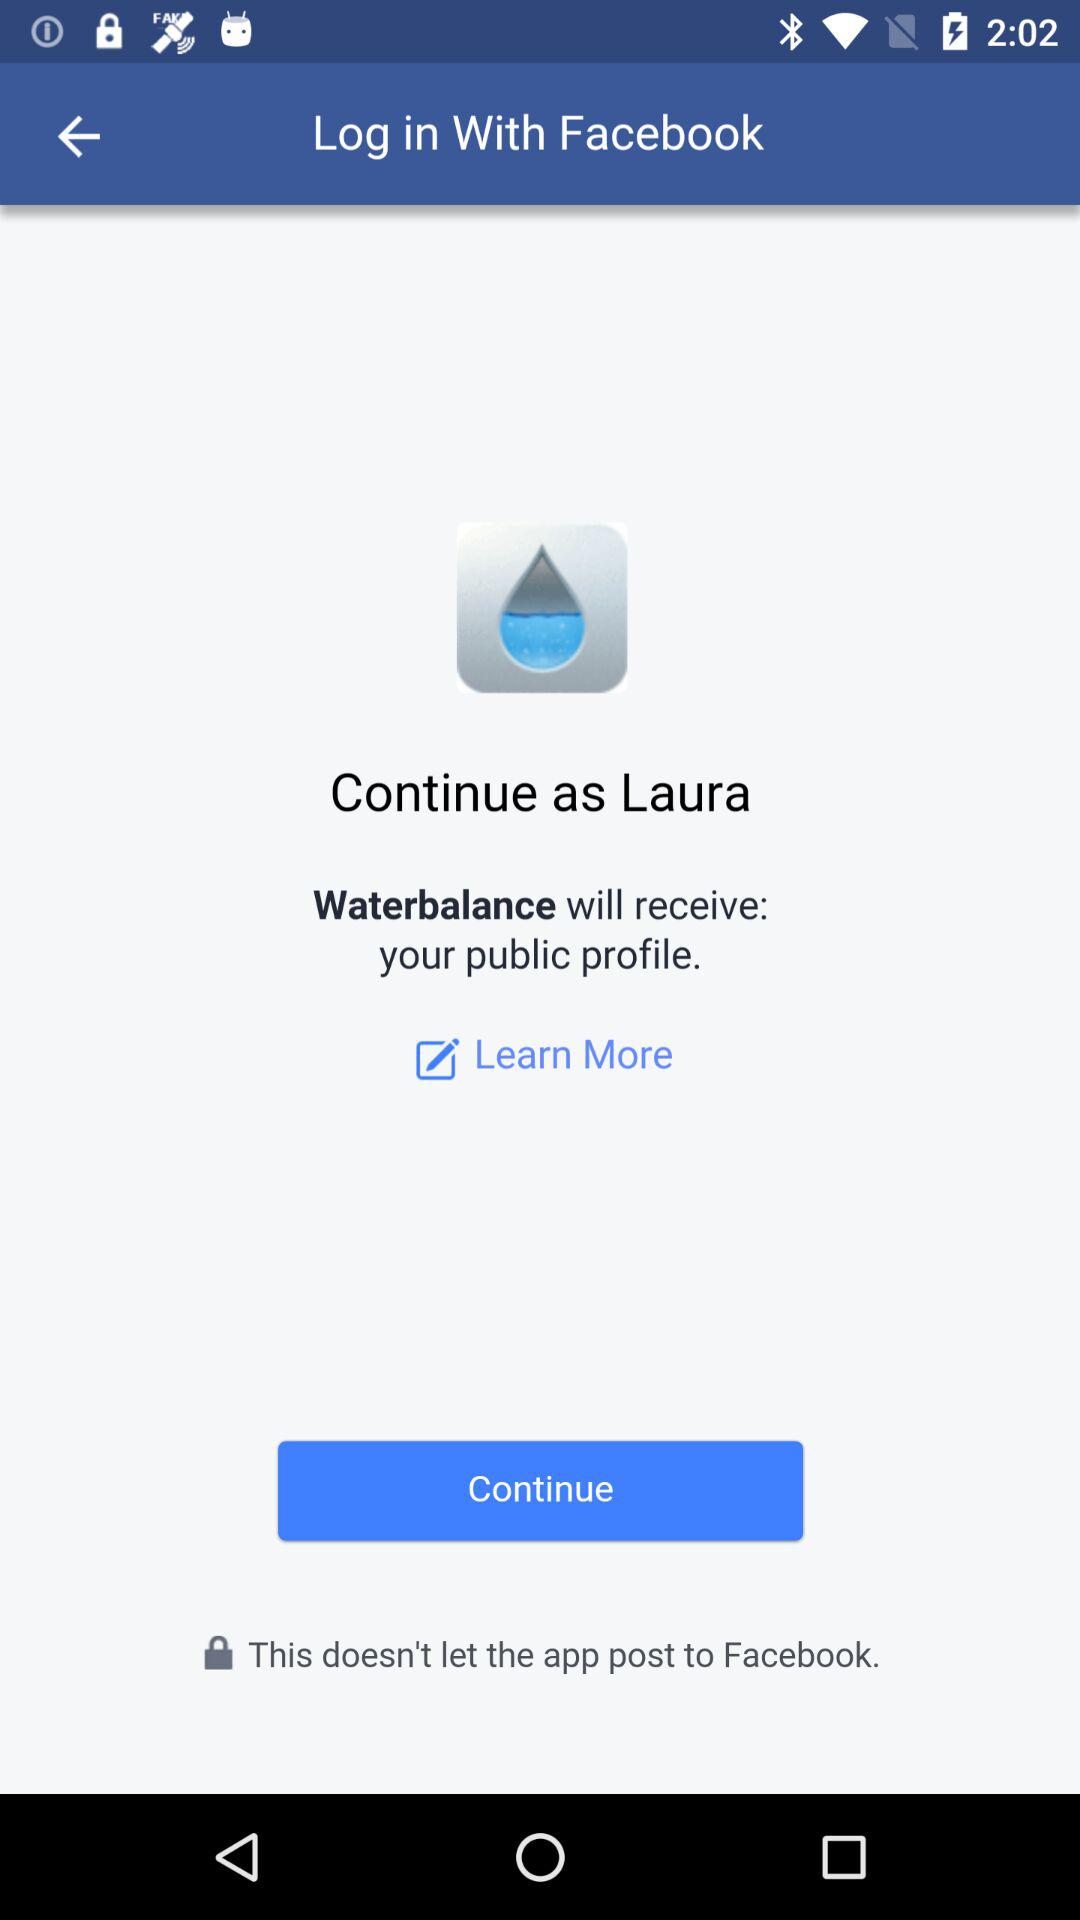What is the user name? The user name is Laura. 